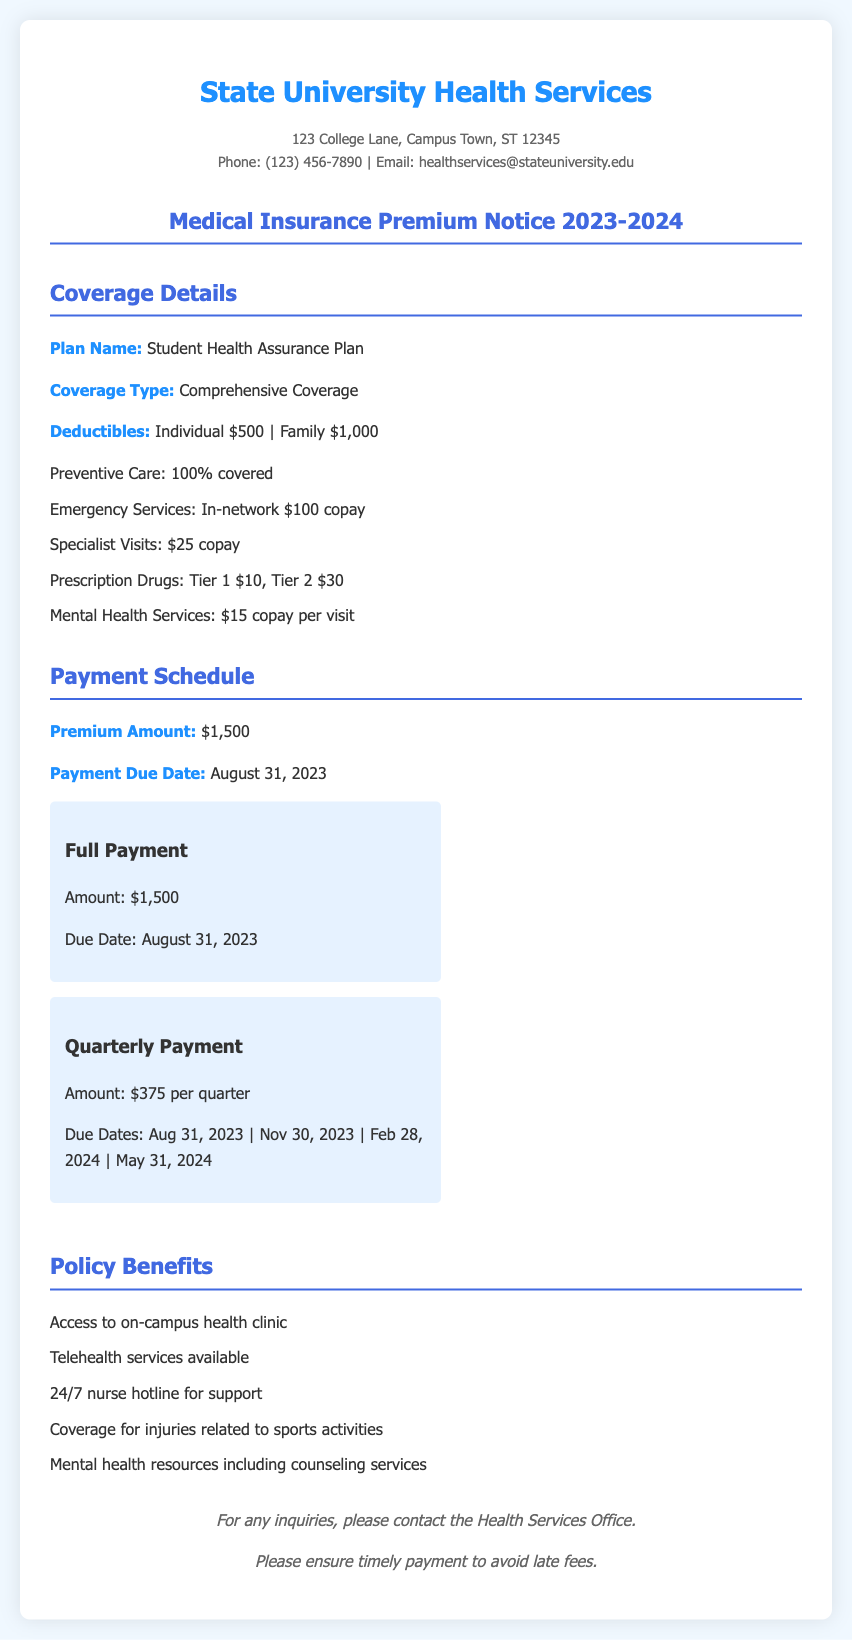What is the premium amount for the insurance? The premium amount is stated clearly in the payment schedule section of the document.
Answer: $1,500 What is the due date for the full payment? The due date for the full payment is specified under the payment schedule.
Answer: August 31, 2023 What is covered at 100% under this plan? Preventive care is indicated as fully covered in the coverage details.
Answer: Preventive Care What is the copay for specialist visits? The copay for specialist visits is stated in the coverage details section.
Answer: $25 How many payment options are available? The document lists two distinct payment options in the payment schedule.
Answer: 2 Which benefit offers support for mental health? The document mentions specific resources for mental health services in the benefits section.
Answer: Counseling services What is the deductible for a family under this plan? The coverage details specify both individual and family deductibles.
Answer: $1,000 How often is the quarterly payment due? The document outlines the payment schedule and lists the due dates for quarterly payments.
Answer: Every three months What type of coverage does this premium offer? The coverage type is stated in the coverage details section.
Answer: Comprehensive Coverage 